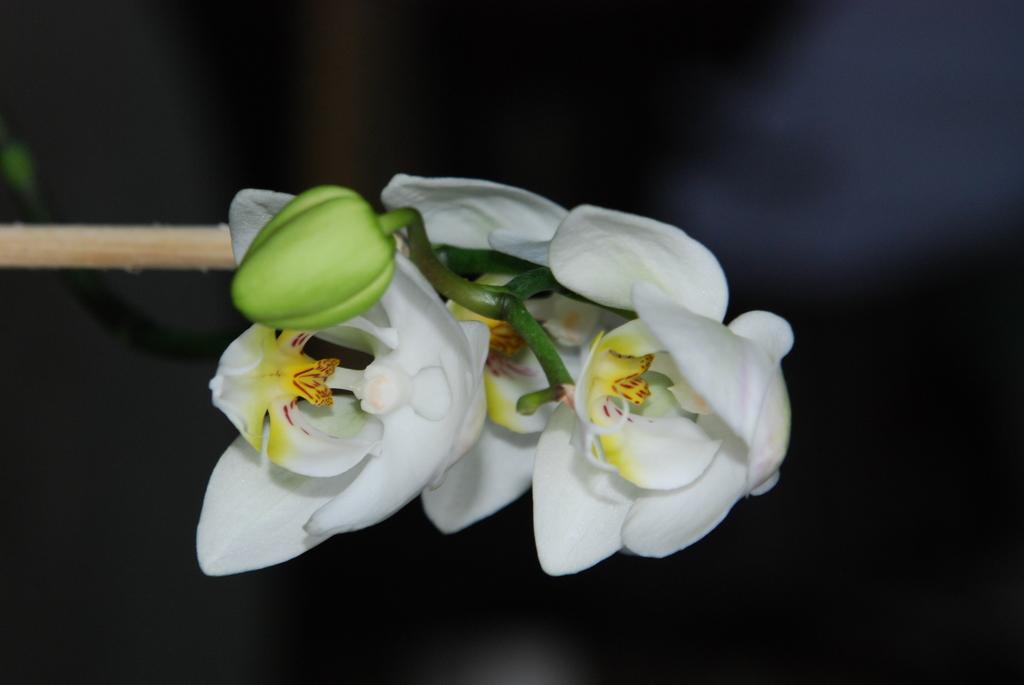How would you summarize this image in a sentence or two? In this image I can see few flowers in white and yellow color and I can see black color background. 